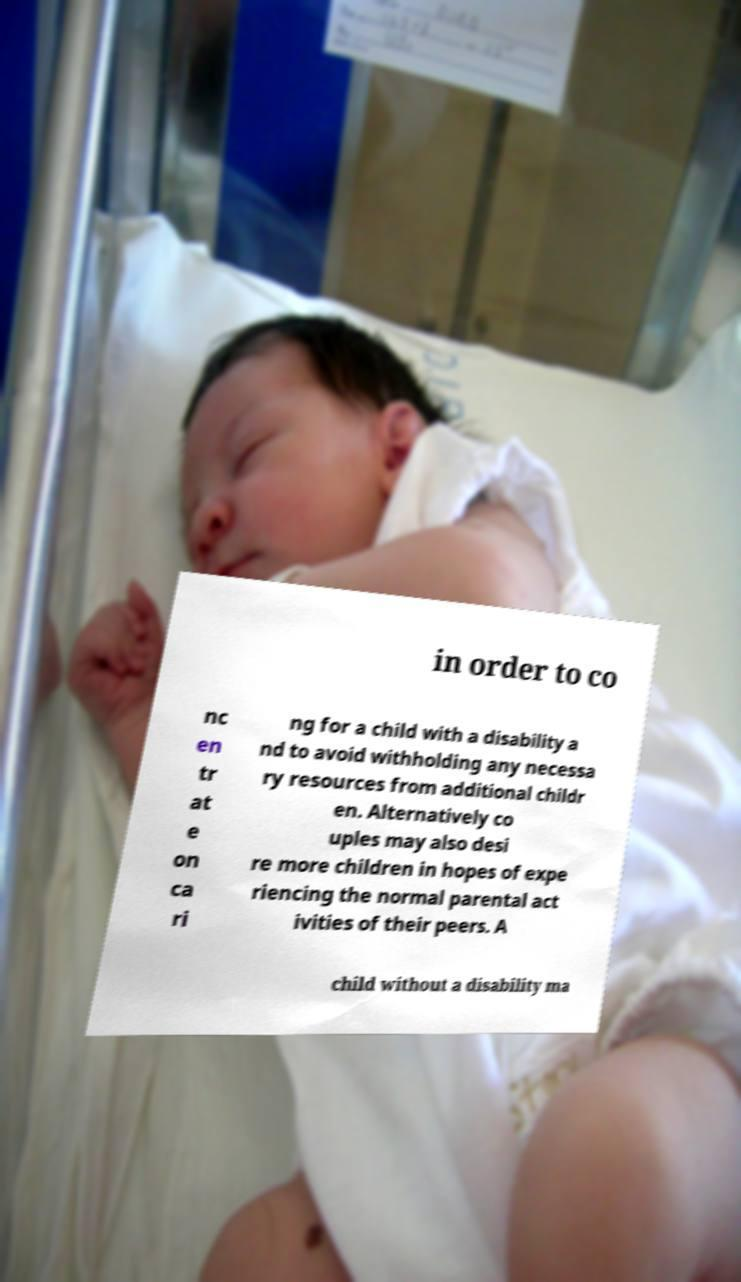Can you read and provide the text displayed in the image?This photo seems to have some interesting text. Can you extract and type it out for me? in order to co nc en tr at e on ca ri ng for a child with a disability a nd to avoid withholding any necessa ry resources from additional childr en. Alternatively co uples may also desi re more children in hopes of expe riencing the normal parental act ivities of their peers. A child without a disability ma 